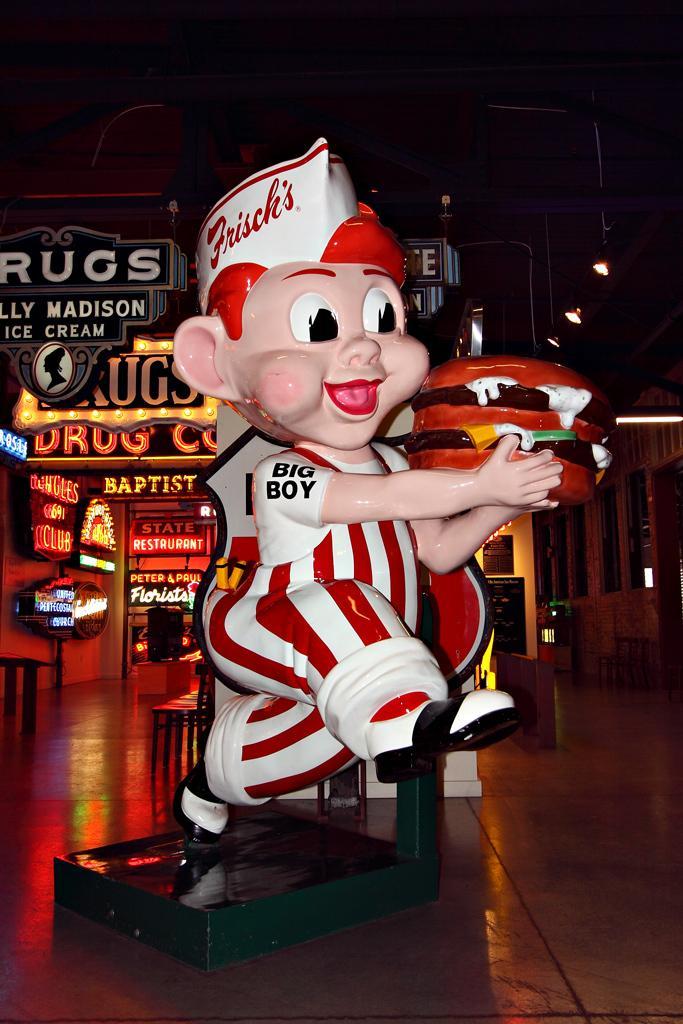How would you summarize this image in a sentence or two? In the center of the image we can see a statue. In the left side of the image we can see come chairs placed on the floor, group of sign boards with some text. On the right side of the image we can see frames on the wall and some lights. 